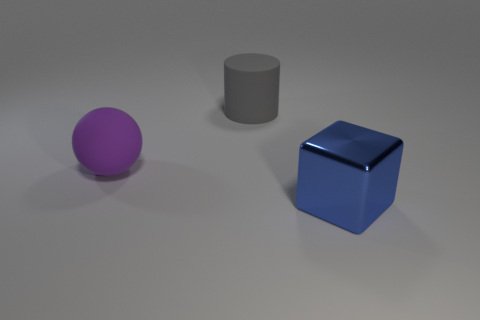Add 2 big purple objects. How many objects exist? 5 Subtract all spheres. How many objects are left? 2 Subtract all large brown shiny spheres. Subtract all big blue metal objects. How many objects are left? 2 Add 1 gray cylinders. How many gray cylinders are left? 2 Add 2 big things. How many big things exist? 5 Subtract 0 brown cylinders. How many objects are left? 3 